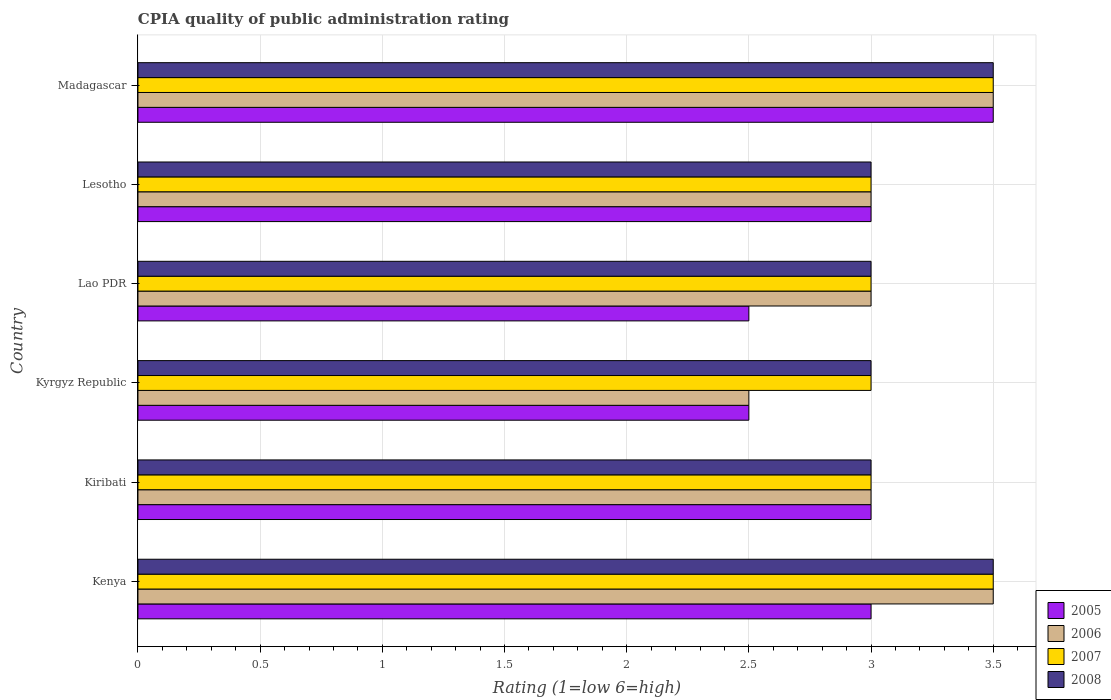How many different coloured bars are there?
Your response must be concise. 4. How many bars are there on the 3rd tick from the bottom?
Make the answer very short. 4. What is the label of the 6th group of bars from the top?
Provide a succinct answer. Kenya. What is the CPIA rating in 2007 in Kiribati?
Your answer should be compact. 3. Across all countries, what is the minimum CPIA rating in 2005?
Keep it short and to the point. 2.5. In which country was the CPIA rating in 2005 maximum?
Give a very brief answer. Madagascar. In which country was the CPIA rating in 2005 minimum?
Offer a terse response. Kyrgyz Republic. What is the difference between the CPIA rating in 2007 in Kenya and the CPIA rating in 2005 in Lesotho?
Your response must be concise. 0.5. What is the average CPIA rating in 2008 per country?
Keep it short and to the point. 3.17. Is the difference between the CPIA rating in 2005 in Kiribati and Lao PDR greater than the difference between the CPIA rating in 2008 in Kiribati and Lao PDR?
Offer a terse response. Yes. What is the difference between the highest and the lowest CPIA rating in 2006?
Your response must be concise. 1. In how many countries, is the CPIA rating in 2008 greater than the average CPIA rating in 2008 taken over all countries?
Your answer should be compact. 2. Is it the case that in every country, the sum of the CPIA rating in 2005 and CPIA rating in 2008 is greater than the sum of CPIA rating in 2007 and CPIA rating in 2006?
Keep it short and to the point. No. How many bars are there?
Offer a very short reply. 24. How many countries are there in the graph?
Provide a short and direct response. 6. Are the values on the major ticks of X-axis written in scientific E-notation?
Offer a very short reply. No. Does the graph contain any zero values?
Offer a terse response. No. Does the graph contain grids?
Offer a very short reply. Yes. How many legend labels are there?
Provide a succinct answer. 4. How are the legend labels stacked?
Keep it short and to the point. Vertical. What is the title of the graph?
Your answer should be compact. CPIA quality of public administration rating. What is the label or title of the X-axis?
Give a very brief answer. Rating (1=low 6=high). What is the Rating (1=low 6=high) of 2005 in Kenya?
Offer a very short reply. 3. What is the Rating (1=low 6=high) in 2008 in Kenya?
Your answer should be compact. 3.5. What is the Rating (1=low 6=high) in 2005 in Kiribati?
Offer a very short reply. 3. What is the Rating (1=low 6=high) in 2006 in Kiribati?
Your response must be concise. 3. What is the Rating (1=low 6=high) of 2005 in Kyrgyz Republic?
Your answer should be compact. 2.5. What is the Rating (1=low 6=high) in 2005 in Lao PDR?
Offer a very short reply. 2.5. What is the Rating (1=low 6=high) in 2008 in Lao PDR?
Provide a short and direct response. 3. What is the Rating (1=low 6=high) in 2005 in Lesotho?
Make the answer very short. 3. What is the Rating (1=low 6=high) of 2006 in Lesotho?
Your answer should be very brief. 3. What is the Rating (1=low 6=high) in 2005 in Madagascar?
Your answer should be compact. 3.5. Across all countries, what is the maximum Rating (1=low 6=high) in 2005?
Your answer should be compact. 3.5. Across all countries, what is the minimum Rating (1=low 6=high) in 2005?
Your answer should be very brief. 2.5. Across all countries, what is the minimum Rating (1=low 6=high) in 2008?
Ensure brevity in your answer.  3. What is the total Rating (1=low 6=high) of 2005 in the graph?
Offer a very short reply. 17.5. What is the total Rating (1=low 6=high) of 2007 in the graph?
Provide a succinct answer. 19. What is the difference between the Rating (1=low 6=high) of 2005 in Kenya and that in Kiribati?
Provide a short and direct response. 0. What is the difference between the Rating (1=low 6=high) in 2006 in Kenya and that in Kiribati?
Provide a succinct answer. 0.5. What is the difference between the Rating (1=low 6=high) of 2007 in Kenya and that in Kiribati?
Your answer should be compact. 0.5. What is the difference between the Rating (1=low 6=high) of 2005 in Kenya and that in Kyrgyz Republic?
Your answer should be compact. 0.5. What is the difference between the Rating (1=low 6=high) of 2006 in Kenya and that in Kyrgyz Republic?
Give a very brief answer. 1. What is the difference between the Rating (1=low 6=high) in 2005 in Kenya and that in Lao PDR?
Make the answer very short. 0.5. What is the difference between the Rating (1=low 6=high) in 2005 in Kenya and that in Lesotho?
Ensure brevity in your answer.  0. What is the difference between the Rating (1=low 6=high) of 2006 in Kenya and that in Lesotho?
Offer a terse response. 0.5. What is the difference between the Rating (1=low 6=high) of 2007 in Kenya and that in Lesotho?
Your answer should be compact. 0.5. What is the difference between the Rating (1=low 6=high) in 2008 in Kenya and that in Lesotho?
Provide a succinct answer. 0.5. What is the difference between the Rating (1=low 6=high) of 2005 in Kenya and that in Madagascar?
Offer a terse response. -0.5. What is the difference between the Rating (1=low 6=high) of 2006 in Kenya and that in Madagascar?
Offer a very short reply. 0. What is the difference between the Rating (1=low 6=high) in 2007 in Kenya and that in Madagascar?
Keep it short and to the point. 0. What is the difference between the Rating (1=low 6=high) in 2008 in Kenya and that in Madagascar?
Offer a terse response. 0. What is the difference between the Rating (1=low 6=high) of 2005 in Kiribati and that in Kyrgyz Republic?
Make the answer very short. 0.5. What is the difference between the Rating (1=low 6=high) in 2006 in Kiribati and that in Kyrgyz Republic?
Your response must be concise. 0.5. What is the difference between the Rating (1=low 6=high) of 2006 in Kiribati and that in Lao PDR?
Provide a short and direct response. 0. What is the difference between the Rating (1=low 6=high) in 2007 in Kiribati and that in Lesotho?
Offer a very short reply. 0. What is the difference between the Rating (1=low 6=high) in 2006 in Kiribati and that in Madagascar?
Provide a succinct answer. -0.5. What is the difference between the Rating (1=low 6=high) of 2007 in Kiribati and that in Madagascar?
Provide a succinct answer. -0.5. What is the difference between the Rating (1=low 6=high) of 2008 in Kiribati and that in Madagascar?
Make the answer very short. -0.5. What is the difference between the Rating (1=low 6=high) of 2005 in Kyrgyz Republic and that in Lesotho?
Offer a very short reply. -0.5. What is the difference between the Rating (1=low 6=high) of 2007 in Kyrgyz Republic and that in Lesotho?
Offer a very short reply. 0. What is the difference between the Rating (1=low 6=high) of 2005 in Kyrgyz Republic and that in Madagascar?
Your answer should be very brief. -1. What is the difference between the Rating (1=low 6=high) of 2006 in Kyrgyz Republic and that in Madagascar?
Ensure brevity in your answer.  -1. What is the difference between the Rating (1=low 6=high) in 2007 in Kyrgyz Republic and that in Madagascar?
Give a very brief answer. -0.5. What is the difference between the Rating (1=low 6=high) in 2008 in Kyrgyz Republic and that in Madagascar?
Provide a succinct answer. -0.5. What is the difference between the Rating (1=low 6=high) in 2005 in Lao PDR and that in Madagascar?
Provide a succinct answer. -1. What is the difference between the Rating (1=low 6=high) in 2008 in Lao PDR and that in Madagascar?
Ensure brevity in your answer.  -0.5. What is the difference between the Rating (1=low 6=high) of 2006 in Lesotho and that in Madagascar?
Provide a short and direct response. -0.5. What is the difference between the Rating (1=low 6=high) of 2005 in Kenya and the Rating (1=low 6=high) of 2007 in Kiribati?
Give a very brief answer. 0. What is the difference between the Rating (1=low 6=high) of 2007 in Kenya and the Rating (1=low 6=high) of 2008 in Kiribati?
Offer a very short reply. 0.5. What is the difference between the Rating (1=low 6=high) of 2005 in Kenya and the Rating (1=low 6=high) of 2008 in Kyrgyz Republic?
Your response must be concise. 0. What is the difference between the Rating (1=low 6=high) of 2006 in Kenya and the Rating (1=low 6=high) of 2008 in Kyrgyz Republic?
Provide a short and direct response. 0.5. What is the difference between the Rating (1=low 6=high) of 2005 in Kenya and the Rating (1=low 6=high) of 2008 in Lao PDR?
Your answer should be compact. 0. What is the difference between the Rating (1=low 6=high) in 2006 in Kenya and the Rating (1=low 6=high) in 2007 in Lao PDR?
Offer a terse response. 0.5. What is the difference between the Rating (1=low 6=high) in 2005 in Kenya and the Rating (1=low 6=high) in 2007 in Lesotho?
Provide a succinct answer. 0. What is the difference between the Rating (1=low 6=high) in 2006 in Kenya and the Rating (1=low 6=high) in 2007 in Lesotho?
Offer a very short reply. 0.5. What is the difference between the Rating (1=low 6=high) of 2006 in Kenya and the Rating (1=low 6=high) of 2008 in Lesotho?
Keep it short and to the point. 0.5. What is the difference between the Rating (1=low 6=high) in 2007 in Kenya and the Rating (1=low 6=high) in 2008 in Lesotho?
Provide a succinct answer. 0.5. What is the difference between the Rating (1=low 6=high) of 2005 in Kenya and the Rating (1=low 6=high) of 2007 in Madagascar?
Your answer should be compact. -0.5. What is the difference between the Rating (1=low 6=high) of 2006 in Kenya and the Rating (1=low 6=high) of 2007 in Madagascar?
Your answer should be very brief. 0. What is the difference between the Rating (1=low 6=high) in 2007 in Kenya and the Rating (1=low 6=high) in 2008 in Madagascar?
Your response must be concise. 0. What is the difference between the Rating (1=low 6=high) of 2005 in Kiribati and the Rating (1=low 6=high) of 2006 in Kyrgyz Republic?
Make the answer very short. 0.5. What is the difference between the Rating (1=low 6=high) of 2005 in Kiribati and the Rating (1=low 6=high) of 2007 in Kyrgyz Republic?
Your response must be concise. 0. What is the difference between the Rating (1=low 6=high) of 2005 in Kiribati and the Rating (1=low 6=high) of 2008 in Kyrgyz Republic?
Provide a succinct answer. 0. What is the difference between the Rating (1=low 6=high) in 2006 in Kiribati and the Rating (1=low 6=high) in 2007 in Kyrgyz Republic?
Provide a succinct answer. 0. What is the difference between the Rating (1=low 6=high) of 2007 in Kiribati and the Rating (1=low 6=high) of 2008 in Kyrgyz Republic?
Provide a succinct answer. 0. What is the difference between the Rating (1=low 6=high) in 2005 in Kiribati and the Rating (1=low 6=high) in 2007 in Lao PDR?
Ensure brevity in your answer.  0. What is the difference between the Rating (1=low 6=high) of 2005 in Kiribati and the Rating (1=low 6=high) of 2008 in Lao PDR?
Provide a short and direct response. 0. What is the difference between the Rating (1=low 6=high) in 2006 in Kiribati and the Rating (1=low 6=high) in 2007 in Lao PDR?
Keep it short and to the point. 0. What is the difference between the Rating (1=low 6=high) of 2007 in Kiribati and the Rating (1=low 6=high) of 2008 in Lao PDR?
Keep it short and to the point. 0. What is the difference between the Rating (1=low 6=high) of 2005 in Kiribati and the Rating (1=low 6=high) of 2008 in Lesotho?
Offer a very short reply. 0. What is the difference between the Rating (1=low 6=high) in 2006 in Kiribati and the Rating (1=low 6=high) in 2007 in Lesotho?
Provide a succinct answer. 0. What is the difference between the Rating (1=low 6=high) in 2007 in Kiribati and the Rating (1=low 6=high) in 2008 in Lesotho?
Ensure brevity in your answer.  0. What is the difference between the Rating (1=low 6=high) of 2005 in Kyrgyz Republic and the Rating (1=low 6=high) of 2006 in Lao PDR?
Provide a succinct answer. -0.5. What is the difference between the Rating (1=low 6=high) of 2005 in Kyrgyz Republic and the Rating (1=low 6=high) of 2007 in Lao PDR?
Offer a terse response. -0.5. What is the difference between the Rating (1=low 6=high) in 2007 in Kyrgyz Republic and the Rating (1=low 6=high) in 2008 in Lao PDR?
Give a very brief answer. 0. What is the difference between the Rating (1=low 6=high) of 2005 in Kyrgyz Republic and the Rating (1=low 6=high) of 2006 in Lesotho?
Offer a terse response. -0.5. What is the difference between the Rating (1=low 6=high) in 2005 in Kyrgyz Republic and the Rating (1=low 6=high) in 2008 in Lesotho?
Your answer should be very brief. -0.5. What is the difference between the Rating (1=low 6=high) of 2006 in Kyrgyz Republic and the Rating (1=low 6=high) of 2008 in Lesotho?
Ensure brevity in your answer.  -0.5. What is the difference between the Rating (1=low 6=high) of 2005 in Kyrgyz Republic and the Rating (1=low 6=high) of 2006 in Madagascar?
Your answer should be very brief. -1. What is the difference between the Rating (1=low 6=high) in 2005 in Kyrgyz Republic and the Rating (1=low 6=high) in 2008 in Madagascar?
Provide a short and direct response. -1. What is the difference between the Rating (1=low 6=high) in 2006 in Kyrgyz Republic and the Rating (1=low 6=high) in 2008 in Madagascar?
Offer a terse response. -1. What is the difference between the Rating (1=low 6=high) in 2005 in Lao PDR and the Rating (1=low 6=high) in 2007 in Lesotho?
Your answer should be very brief. -0.5. What is the difference between the Rating (1=low 6=high) in 2006 in Lao PDR and the Rating (1=low 6=high) in 2007 in Lesotho?
Keep it short and to the point. 0. What is the difference between the Rating (1=low 6=high) of 2006 in Lao PDR and the Rating (1=low 6=high) of 2008 in Lesotho?
Offer a very short reply. 0. What is the difference between the Rating (1=low 6=high) in 2007 in Lao PDR and the Rating (1=low 6=high) in 2008 in Lesotho?
Ensure brevity in your answer.  0. What is the difference between the Rating (1=low 6=high) in 2005 in Lao PDR and the Rating (1=low 6=high) in 2006 in Madagascar?
Provide a short and direct response. -1. What is the difference between the Rating (1=low 6=high) of 2005 in Lao PDR and the Rating (1=low 6=high) of 2007 in Madagascar?
Offer a very short reply. -1. What is the difference between the Rating (1=low 6=high) in 2005 in Lao PDR and the Rating (1=low 6=high) in 2008 in Madagascar?
Provide a succinct answer. -1. What is the difference between the Rating (1=low 6=high) in 2006 in Lao PDR and the Rating (1=low 6=high) in 2007 in Madagascar?
Offer a very short reply. -0.5. What is the difference between the Rating (1=low 6=high) in 2007 in Lao PDR and the Rating (1=low 6=high) in 2008 in Madagascar?
Your answer should be very brief. -0.5. What is the difference between the Rating (1=low 6=high) in 2005 in Lesotho and the Rating (1=low 6=high) in 2008 in Madagascar?
Ensure brevity in your answer.  -0.5. What is the average Rating (1=low 6=high) in 2005 per country?
Your response must be concise. 2.92. What is the average Rating (1=low 6=high) in 2006 per country?
Ensure brevity in your answer.  3.08. What is the average Rating (1=low 6=high) of 2007 per country?
Your answer should be compact. 3.17. What is the average Rating (1=low 6=high) in 2008 per country?
Your response must be concise. 3.17. What is the difference between the Rating (1=low 6=high) in 2005 and Rating (1=low 6=high) in 2008 in Kenya?
Your answer should be compact. -0.5. What is the difference between the Rating (1=low 6=high) of 2007 and Rating (1=low 6=high) of 2008 in Kenya?
Offer a very short reply. 0. What is the difference between the Rating (1=low 6=high) of 2005 and Rating (1=low 6=high) of 2008 in Kiribati?
Ensure brevity in your answer.  0. What is the difference between the Rating (1=low 6=high) of 2005 and Rating (1=low 6=high) of 2008 in Kyrgyz Republic?
Make the answer very short. -0.5. What is the difference between the Rating (1=low 6=high) in 2007 and Rating (1=low 6=high) in 2008 in Kyrgyz Republic?
Offer a very short reply. 0. What is the difference between the Rating (1=low 6=high) in 2007 and Rating (1=low 6=high) in 2008 in Lao PDR?
Offer a very short reply. 0. What is the difference between the Rating (1=low 6=high) in 2005 and Rating (1=low 6=high) in 2006 in Lesotho?
Give a very brief answer. 0. What is the difference between the Rating (1=low 6=high) of 2005 and Rating (1=low 6=high) of 2007 in Lesotho?
Your response must be concise. 0. What is the difference between the Rating (1=low 6=high) in 2005 and Rating (1=low 6=high) in 2008 in Lesotho?
Provide a succinct answer. 0. What is the difference between the Rating (1=low 6=high) in 2006 and Rating (1=low 6=high) in 2007 in Lesotho?
Make the answer very short. 0. What is the difference between the Rating (1=low 6=high) in 2005 and Rating (1=low 6=high) in 2007 in Madagascar?
Your answer should be very brief. 0. What is the difference between the Rating (1=low 6=high) of 2005 and Rating (1=low 6=high) of 2008 in Madagascar?
Offer a very short reply. 0. What is the difference between the Rating (1=low 6=high) in 2006 and Rating (1=low 6=high) in 2008 in Madagascar?
Your answer should be very brief. 0. What is the difference between the Rating (1=low 6=high) in 2007 and Rating (1=low 6=high) in 2008 in Madagascar?
Give a very brief answer. 0. What is the ratio of the Rating (1=low 6=high) in 2007 in Kenya to that in Kiribati?
Provide a succinct answer. 1.17. What is the ratio of the Rating (1=low 6=high) of 2005 in Kenya to that in Kyrgyz Republic?
Your answer should be very brief. 1.2. What is the ratio of the Rating (1=low 6=high) in 2007 in Kenya to that in Lao PDR?
Make the answer very short. 1.17. What is the ratio of the Rating (1=low 6=high) of 2005 in Kenya to that in Lesotho?
Provide a succinct answer. 1. What is the ratio of the Rating (1=low 6=high) of 2006 in Kenya to that in Lesotho?
Ensure brevity in your answer.  1.17. What is the ratio of the Rating (1=low 6=high) in 2008 in Kenya to that in Lesotho?
Provide a succinct answer. 1.17. What is the ratio of the Rating (1=low 6=high) in 2006 in Kenya to that in Madagascar?
Give a very brief answer. 1. What is the ratio of the Rating (1=low 6=high) of 2008 in Kenya to that in Madagascar?
Your answer should be very brief. 1. What is the ratio of the Rating (1=low 6=high) in 2005 in Kiribati to that in Kyrgyz Republic?
Your response must be concise. 1.2. What is the ratio of the Rating (1=low 6=high) of 2006 in Kiribati to that in Kyrgyz Republic?
Make the answer very short. 1.2. What is the ratio of the Rating (1=low 6=high) of 2005 in Kiribati to that in Lao PDR?
Your answer should be compact. 1.2. What is the ratio of the Rating (1=low 6=high) in 2005 in Kiribati to that in Lesotho?
Make the answer very short. 1. What is the ratio of the Rating (1=low 6=high) of 2007 in Kiribati to that in Lesotho?
Provide a succinct answer. 1. What is the ratio of the Rating (1=low 6=high) in 2005 in Kiribati to that in Madagascar?
Provide a short and direct response. 0.86. What is the ratio of the Rating (1=low 6=high) of 2007 in Kiribati to that in Madagascar?
Make the answer very short. 0.86. What is the ratio of the Rating (1=low 6=high) of 2008 in Kiribati to that in Madagascar?
Your answer should be very brief. 0.86. What is the ratio of the Rating (1=low 6=high) in 2005 in Kyrgyz Republic to that in Lao PDR?
Your answer should be very brief. 1. What is the ratio of the Rating (1=low 6=high) of 2007 in Kyrgyz Republic to that in Lao PDR?
Ensure brevity in your answer.  1. What is the ratio of the Rating (1=low 6=high) in 2006 in Kyrgyz Republic to that in Lesotho?
Offer a very short reply. 0.83. What is the ratio of the Rating (1=low 6=high) in 2007 in Kyrgyz Republic to that in Lesotho?
Provide a short and direct response. 1. What is the ratio of the Rating (1=low 6=high) in 2008 in Kyrgyz Republic to that in Lesotho?
Your answer should be very brief. 1. What is the ratio of the Rating (1=low 6=high) of 2005 in Kyrgyz Republic to that in Madagascar?
Your answer should be very brief. 0.71. What is the ratio of the Rating (1=low 6=high) of 2007 in Kyrgyz Republic to that in Madagascar?
Offer a very short reply. 0.86. What is the ratio of the Rating (1=low 6=high) of 2008 in Lao PDR to that in Lesotho?
Keep it short and to the point. 1. What is the ratio of the Rating (1=low 6=high) of 2005 in Lao PDR to that in Madagascar?
Provide a short and direct response. 0.71. What is the ratio of the Rating (1=low 6=high) in 2006 in Lao PDR to that in Madagascar?
Provide a short and direct response. 0.86. What is the ratio of the Rating (1=low 6=high) in 2008 in Lao PDR to that in Madagascar?
Give a very brief answer. 0.86. What is the ratio of the Rating (1=low 6=high) of 2007 in Lesotho to that in Madagascar?
Your answer should be compact. 0.86. What is the ratio of the Rating (1=low 6=high) in 2008 in Lesotho to that in Madagascar?
Offer a terse response. 0.86. What is the difference between the highest and the second highest Rating (1=low 6=high) of 2008?
Keep it short and to the point. 0. What is the difference between the highest and the lowest Rating (1=low 6=high) of 2005?
Ensure brevity in your answer.  1. What is the difference between the highest and the lowest Rating (1=low 6=high) in 2007?
Offer a terse response. 0.5. What is the difference between the highest and the lowest Rating (1=low 6=high) of 2008?
Your answer should be very brief. 0.5. 